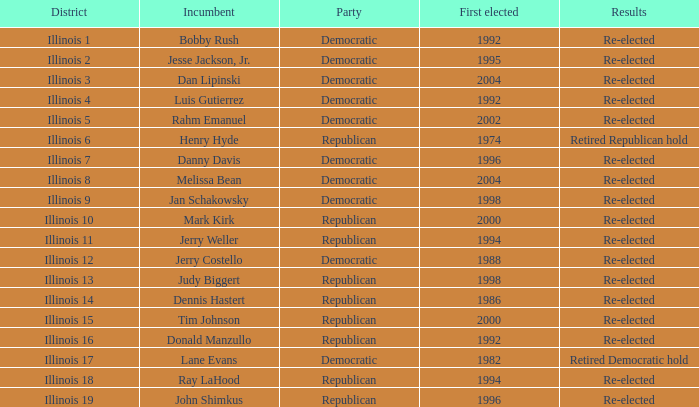On what date was jerry costello, the re-elected incumbent, initially elected? 1988.0. 